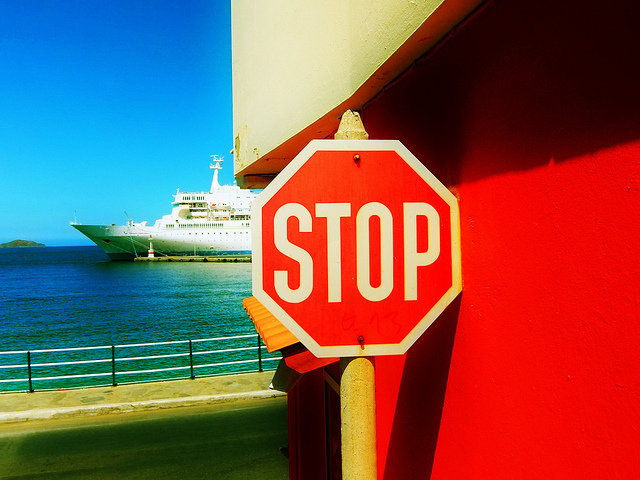How would you describe the vibe or atmosphere of the location in the image? The overall atmosphere of the image appears serene and leisurely, characterized by the bright blue sky, the calm water, and the presence of the passenger ship, which suggests a location that could be popular for vacations or tourism. The vibrancy of the red barrier adds a pop of color that creates a striking contrast against the blues of the sea and sky. 